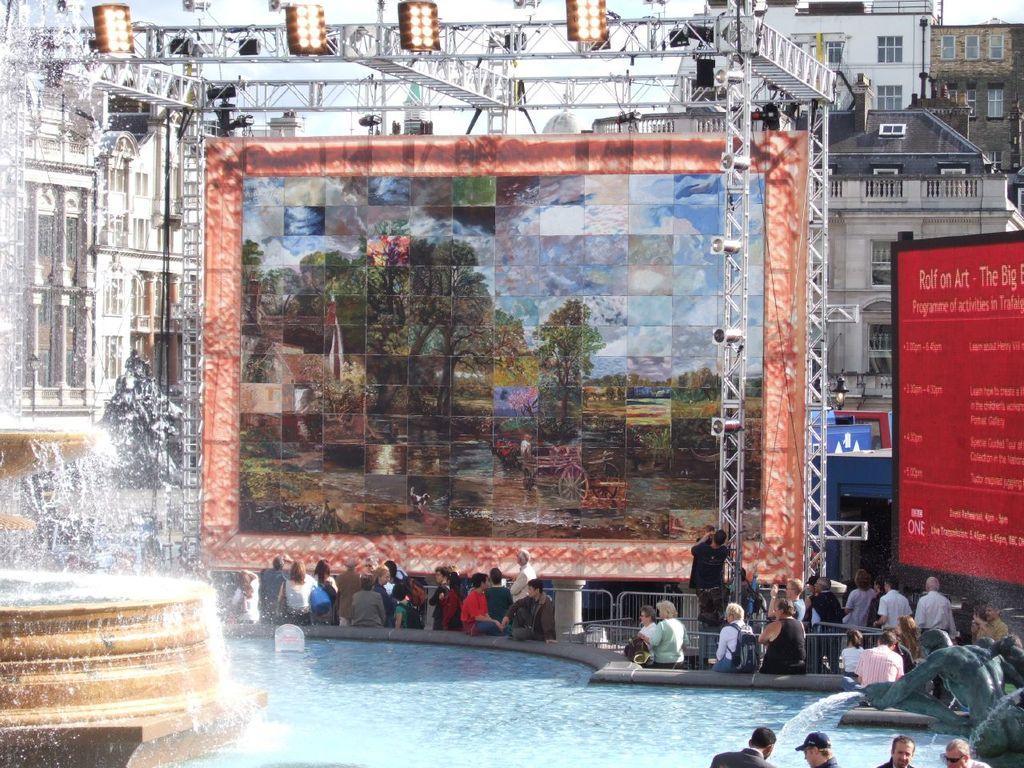Could you give a brief overview of what you see in this image? This picture describes about group of people, few are seated and few are standing, on the left side of the image we can see a fountain, in the background we can find few metal rods, lights, buildings and a screen, on the right side of the image we can find a statue and a hoarding, also we can see a pool. 